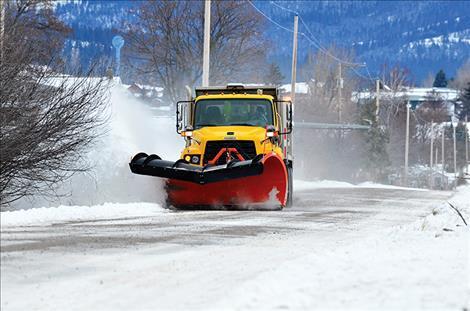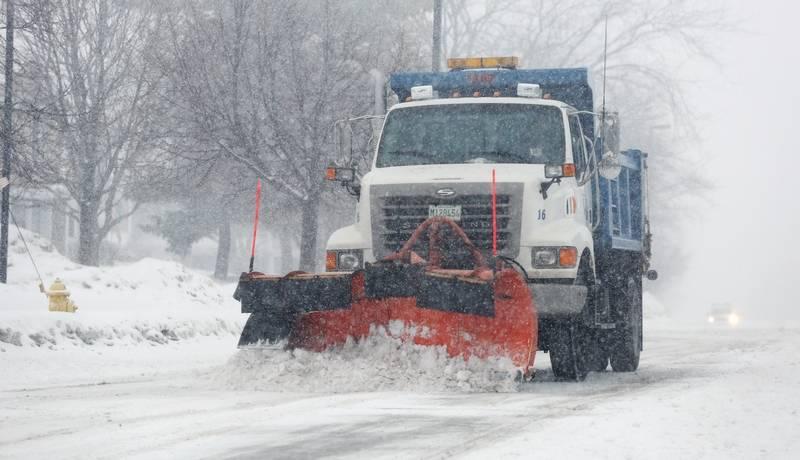The first image is the image on the left, the second image is the image on the right. Evaluate the accuracy of this statement regarding the images: "There is a white vehicle.". Is it true? Answer yes or no. Yes. The first image is the image on the left, the second image is the image on the right. Given the left and right images, does the statement "The left and right image contains the same number of snow scraper trucks plowing a road." hold true? Answer yes or no. Yes. 